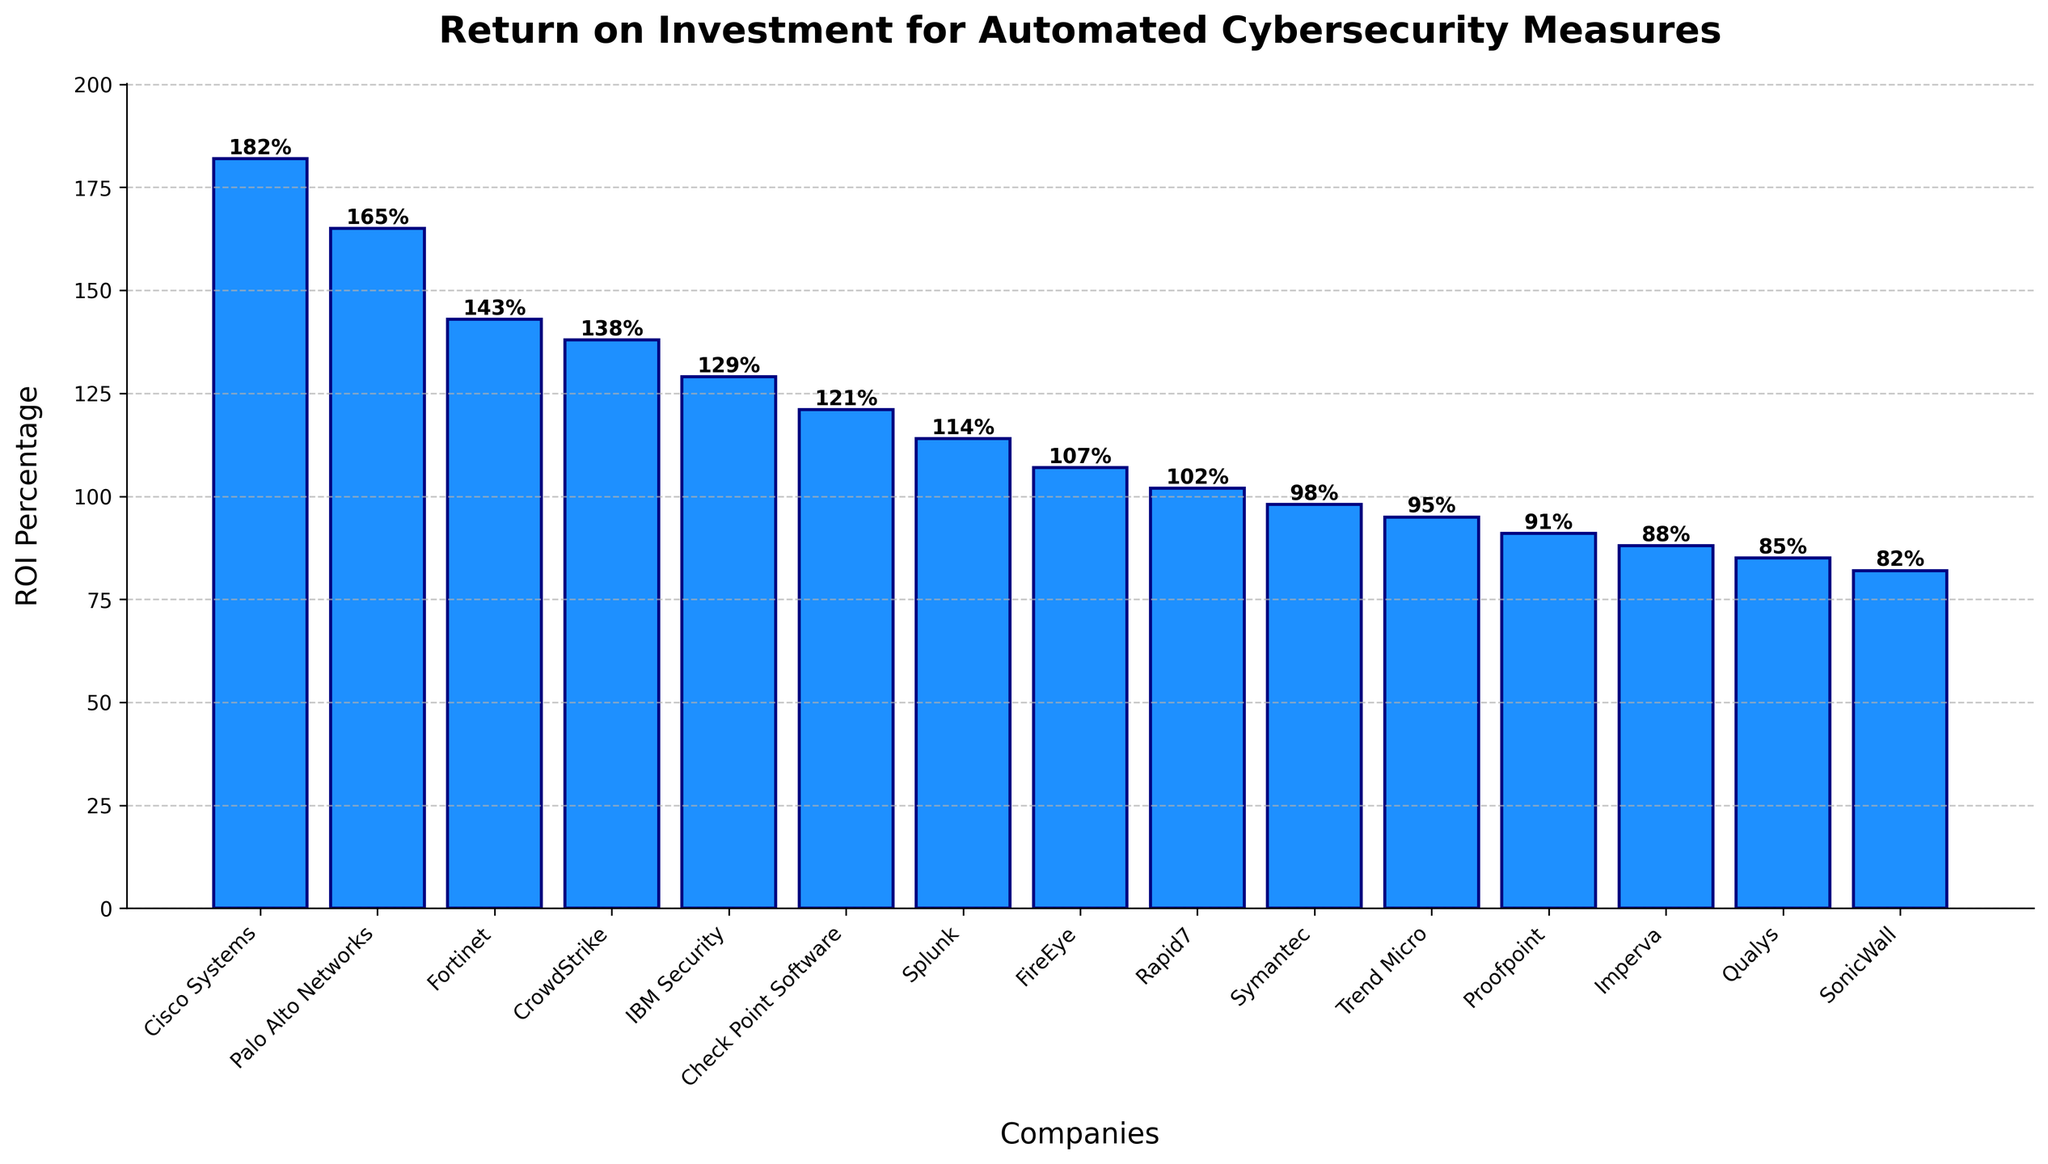Which company has the highest ROI in the chart? Look at the bar chart and identify the bar with the highest height. Cisco Systems has the highest bar.
Answer: Cisco Systems Which company has the lowest ROI in the chart? Look at the bar chart and identify the bar with the lowest height. SonicWall has the lowest bar.
Answer: SonicWall What's the difference in ROI between Cisco Systems and Symantec? Find the heights of the bars for Cisco Systems and Symantec. Cisco Systems is 182% and Symantec is 98%. Subtract Symantec's ROI from Cisco Systems' ROI: 182 - 98.
Answer: 84% Which companies have an ROI percentage greater than 150%? Identify bars with heights more than 150%. The companies are Cisco Systems and Palo Alto Networks.
Answer: Cisco Systems, Palo Alto Networks What is the average ROI percentage for all companies? Sum all the ROI percentages and divide by the number of companies. Total sum is 182 + 165 + 143 + 138 + 129 + 121 + 114 + 107 + 102 + 98 + 95 + 91 + 88 + 85 + 82 = 1660. There are 15 companies. 1660 / 15.
Answer: 110.67% What is the median ROI percentage for all companies? To find the median, list all ROI percentages in ascending order and find the middle value. The sorted ROIs: 82, 85, 88, 91, 95, 98, 102, 107, 114, 121, 129, 138, 143, 165, 182. The median (middle) value is the 8th value, which is 107.
Answer: 107% What's the sum of the ROI percentages for Fortinet and CrowdStrike? Add the ROI percentages of Fortinet (143%) and CrowdStrike (138%). 143 + 138.
Answer: 281% Compare the ROIs of FireEye and Rapid7. Which one is higher and by how much? Find the heights of the bars for FireEye and Rapid7. FireEye is 107% and Rapid7 is 102%. Subtract Rapid7's ROI from FireEye's ROI: 107 - 102.
Answer: FireEye, 5% How many companies have an ROI percentage less than 100%? Count the number of bars with heights less than 100%. The companies are Symantec, Trend Micro, Proofpoint, Imperva, Qualys, SonicWall. There are 6 companies.
Answer: 6 